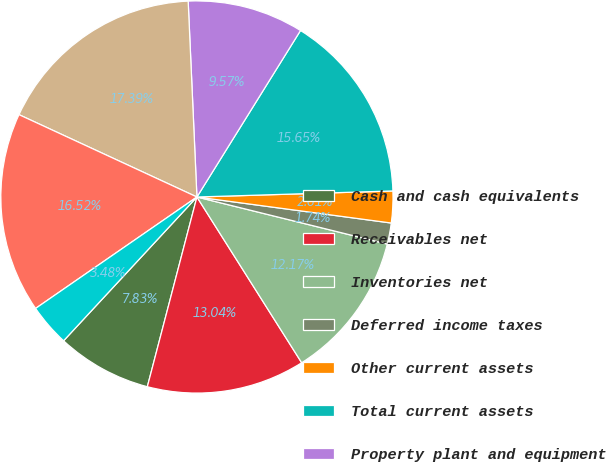Convert chart to OTSL. <chart><loc_0><loc_0><loc_500><loc_500><pie_chart><fcel>Cash and cash equivalents<fcel>Receivables net<fcel>Inventories net<fcel>Deferred income taxes<fcel>Other current assets<fcel>Total current assets<fcel>Property plant and equipment<fcel>Goodwill<fcel>Other intangibles net<fcel>Investments and other assets<nl><fcel>7.83%<fcel>13.04%<fcel>12.17%<fcel>1.74%<fcel>2.61%<fcel>15.65%<fcel>9.57%<fcel>17.39%<fcel>16.52%<fcel>3.48%<nl></chart> 